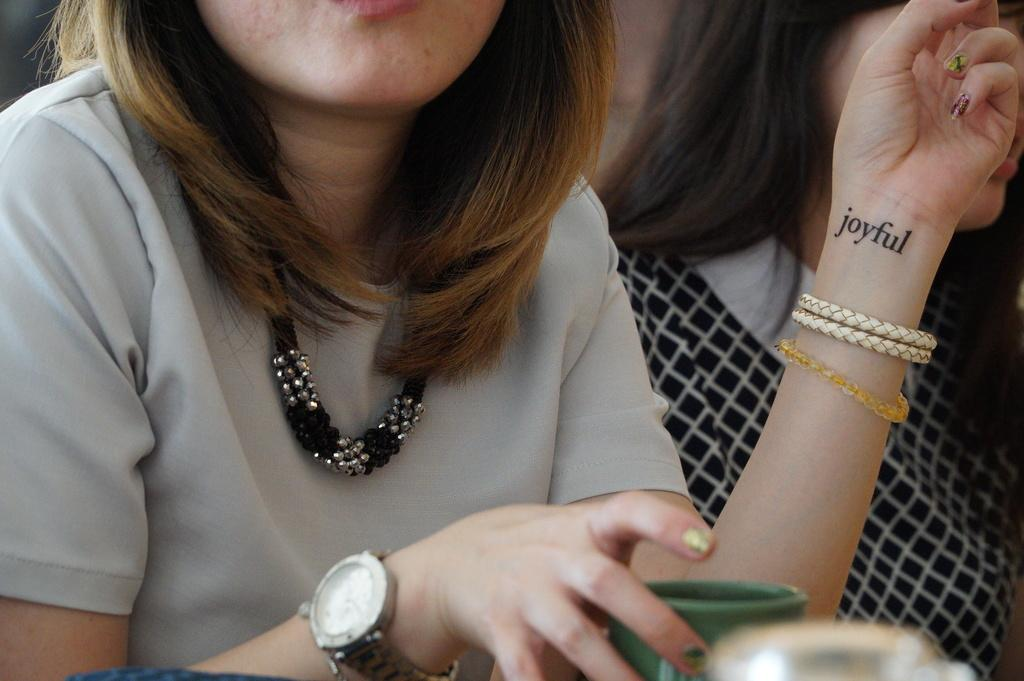<image>
Share a concise interpretation of the image provided. A woman with the word joyful tattooed on her wrist is sitting with a mug in front of her. 